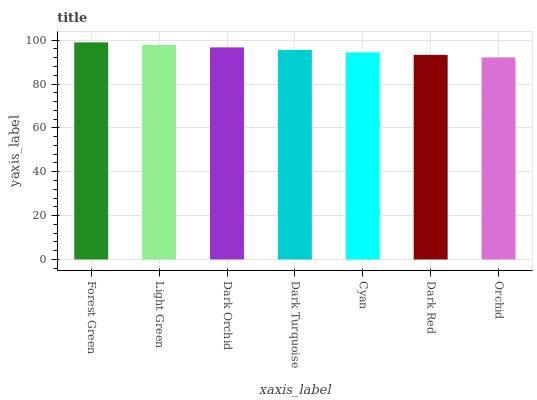Is Orchid the minimum?
Answer yes or no. Yes. Is Forest Green the maximum?
Answer yes or no. Yes. Is Light Green the minimum?
Answer yes or no. No. Is Light Green the maximum?
Answer yes or no. No. Is Forest Green greater than Light Green?
Answer yes or no. Yes. Is Light Green less than Forest Green?
Answer yes or no. Yes. Is Light Green greater than Forest Green?
Answer yes or no. No. Is Forest Green less than Light Green?
Answer yes or no. No. Is Dark Turquoise the high median?
Answer yes or no. Yes. Is Dark Turquoise the low median?
Answer yes or no. Yes. Is Cyan the high median?
Answer yes or no. No. Is Dark Red the low median?
Answer yes or no. No. 